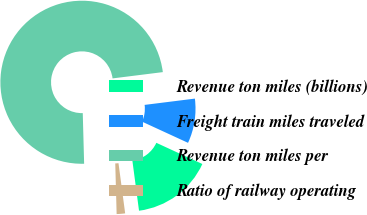<chart> <loc_0><loc_0><loc_500><loc_500><pie_chart><fcel>Revenue ton miles (billions)<fcel>Freight train miles traveled<fcel>Revenue ton miles per<fcel>Ratio of railway operating<nl><fcel>16.03%<fcel>8.85%<fcel>73.45%<fcel>1.67%<nl></chart> 